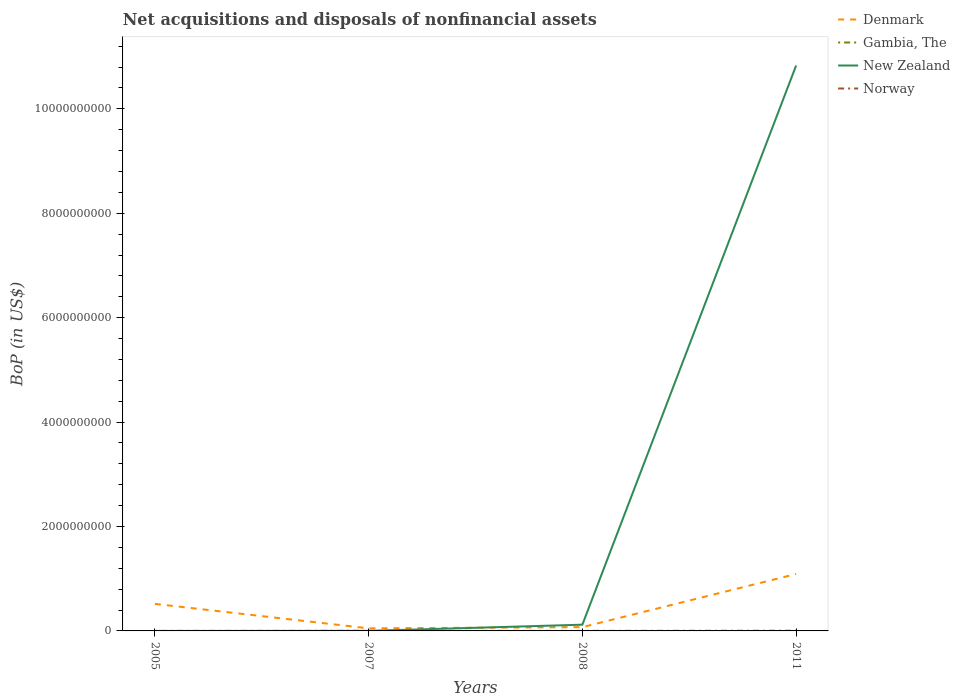How many different coloured lines are there?
Your response must be concise. 3. Is the number of lines equal to the number of legend labels?
Ensure brevity in your answer.  No. Across all years, what is the maximum Balance of Payments in Norway?
Your answer should be very brief. 0. What is the total Balance of Payments in Gambia, The in the graph?
Provide a succinct answer. -3.56e+06. What is the difference between the highest and the second highest Balance of Payments in Denmark?
Offer a very short reply. 1.04e+09. What is the difference between the highest and the lowest Balance of Payments in Norway?
Keep it short and to the point. 0. Is the Balance of Payments in Denmark strictly greater than the Balance of Payments in New Zealand over the years?
Give a very brief answer. No. What is the difference between two consecutive major ticks on the Y-axis?
Make the answer very short. 2.00e+09. Where does the legend appear in the graph?
Offer a terse response. Top right. What is the title of the graph?
Offer a terse response. Net acquisitions and disposals of nonfinancial assets. What is the label or title of the X-axis?
Offer a very short reply. Years. What is the label or title of the Y-axis?
Provide a short and direct response. BoP (in US$). What is the BoP (in US$) of Denmark in 2005?
Your answer should be very brief. 5.18e+08. What is the BoP (in US$) in Gambia, The in 2005?
Provide a short and direct response. 5.98e+05. What is the BoP (in US$) in Norway in 2005?
Your answer should be compact. 0. What is the BoP (in US$) in Denmark in 2007?
Give a very brief answer. 4.93e+07. What is the BoP (in US$) in Gambia, The in 2007?
Make the answer very short. 2.07e+06. What is the BoP (in US$) in New Zealand in 2007?
Provide a succinct answer. 7.64e+05. What is the BoP (in US$) in Norway in 2007?
Your answer should be very brief. 0. What is the BoP (in US$) in Denmark in 2008?
Ensure brevity in your answer.  7.29e+07. What is the BoP (in US$) of Gambia, The in 2008?
Make the answer very short. 1.17e+06. What is the BoP (in US$) of New Zealand in 2008?
Make the answer very short. 1.19e+08. What is the BoP (in US$) in Denmark in 2011?
Ensure brevity in your answer.  1.09e+09. What is the BoP (in US$) in Gambia, The in 2011?
Your response must be concise. 4.15e+06. What is the BoP (in US$) of New Zealand in 2011?
Ensure brevity in your answer.  1.08e+1. Across all years, what is the maximum BoP (in US$) in Denmark?
Your answer should be compact. 1.09e+09. Across all years, what is the maximum BoP (in US$) in Gambia, The?
Provide a succinct answer. 4.15e+06. Across all years, what is the maximum BoP (in US$) in New Zealand?
Provide a succinct answer. 1.08e+1. Across all years, what is the minimum BoP (in US$) of Denmark?
Offer a very short reply. 4.93e+07. Across all years, what is the minimum BoP (in US$) in Gambia, The?
Make the answer very short. 5.98e+05. What is the total BoP (in US$) of Denmark in the graph?
Keep it short and to the point. 1.73e+09. What is the total BoP (in US$) of Gambia, The in the graph?
Offer a very short reply. 7.99e+06. What is the total BoP (in US$) in New Zealand in the graph?
Provide a short and direct response. 1.09e+1. What is the difference between the BoP (in US$) in Denmark in 2005 and that in 2007?
Give a very brief answer. 4.69e+08. What is the difference between the BoP (in US$) of Gambia, The in 2005 and that in 2007?
Provide a succinct answer. -1.47e+06. What is the difference between the BoP (in US$) in Denmark in 2005 and that in 2008?
Offer a very short reply. 4.45e+08. What is the difference between the BoP (in US$) in Gambia, The in 2005 and that in 2008?
Your response must be concise. -5.74e+05. What is the difference between the BoP (in US$) in Denmark in 2005 and that in 2011?
Give a very brief answer. -5.72e+08. What is the difference between the BoP (in US$) of Gambia, The in 2005 and that in 2011?
Provide a succinct answer. -3.56e+06. What is the difference between the BoP (in US$) in Denmark in 2007 and that in 2008?
Keep it short and to the point. -2.35e+07. What is the difference between the BoP (in US$) of Gambia, The in 2007 and that in 2008?
Your response must be concise. 8.96e+05. What is the difference between the BoP (in US$) in New Zealand in 2007 and that in 2008?
Make the answer very short. -1.19e+08. What is the difference between the BoP (in US$) in Denmark in 2007 and that in 2011?
Ensure brevity in your answer.  -1.04e+09. What is the difference between the BoP (in US$) of Gambia, The in 2007 and that in 2011?
Provide a short and direct response. -2.09e+06. What is the difference between the BoP (in US$) in New Zealand in 2007 and that in 2011?
Offer a terse response. -1.08e+1. What is the difference between the BoP (in US$) in Denmark in 2008 and that in 2011?
Provide a succinct answer. -1.02e+09. What is the difference between the BoP (in US$) in Gambia, The in 2008 and that in 2011?
Your answer should be compact. -2.98e+06. What is the difference between the BoP (in US$) in New Zealand in 2008 and that in 2011?
Provide a succinct answer. -1.07e+1. What is the difference between the BoP (in US$) in Denmark in 2005 and the BoP (in US$) in Gambia, The in 2007?
Keep it short and to the point. 5.16e+08. What is the difference between the BoP (in US$) of Denmark in 2005 and the BoP (in US$) of New Zealand in 2007?
Your response must be concise. 5.17e+08. What is the difference between the BoP (in US$) of Gambia, The in 2005 and the BoP (in US$) of New Zealand in 2007?
Your answer should be very brief. -1.65e+05. What is the difference between the BoP (in US$) of Denmark in 2005 and the BoP (in US$) of Gambia, The in 2008?
Your answer should be compact. 5.17e+08. What is the difference between the BoP (in US$) in Denmark in 2005 and the BoP (in US$) in New Zealand in 2008?
Provide a short and direct response. 3.99e+08. What is the difference between the BoP (in US$) in Gambia, The in 2005 and the BoP (in US$) in New Zealand in 2008?
Provide a succinct answer. -1.19e+08. What is the difference between the BoP (in US$) in Denmark in 2005 and the BoP (in US$) in Gambia, The in 2011?
Offer a terse response. 5.14e+08. What is the difference between the BoP (in US$) of Denmark in 2005 and the BoP (in US$) of New Zealand in 2011?
Make the answer very short. -1.03e+1. What is the difference between the BoP (in US$) of Gambia, The in 2005 and the BoP (in US$) of New Zealand in 2011?
Offer a terse response. -1.08e+1. What is the difference between the BoP (in US$) of Denmark in 2007 and the BoP (in US$) of Gambia, The in 2008?
Keep it short and to the point. 4.81e+07. What is the difference between the BoP (in US$) of Denmark in 2007 and the BoP (in US$) of New Zealand in 2008?
Keep it short and to the point. -7.01e+07. What is the difference between the BoP (in US$) in Gambia, The in 2007 and the BoP (in US$) in New Zealand in 2008?
Your answer should be compact. -1.17e+08. What is the difference between the BoP (in US$) in Denmark in 2007 and the BoP (in US$) in Gambia, The in 2011?
Your answer should be very brief. 4.52e+07. What is the difference between the BoP (in US$) in Denmark in 2007 and the BoP (in US$) in New Zealand in 2011?
Keep it short and to the point. -1.08e+1. What is the difference between the BoP (in US$) in Gambia, The in 2007 and the BoP (in US$) in New Zealand in 2011?
Your answer should be very brief. -1.08e+1. What is the difference between the BoP (in US$) in Denmark in 2008 and the BoP (in US$) in Gambia, The in 2011?
Give a very brief answer. 6.87e+07. What is the difference between the BoP (in US$) in Denmark in 2008 and the BoP (in US$) in New Zealand in 2011?
Offer a terse response. -1.08e+1. What is the difference between the BoP (in US$) of Gambia, The in 2008 and the BoP (in US$) of New Zealand in 2011?
Offer a terse response. -1.08e+1. What is the average BoP (in US$) of Denmark per year?
Your response must be concise. 4.33e+08. What is the average BoP (in US$) of Gambia, The per year?
Give a very brief answer. 2.00e+06. What is the average BoP (in US$) of New Zealand per year?
Your answer should be compact. 2.74e+09. In the year 2005, what is the difference between the BoP (in US$) of Denmark and BoP (in US$) of Gambia, The?
Give a very brief answer. 5.17e+08. In the year 2007, what is the difference between the BoP (in US$) in Denmark and BoP (in US$) in Gambia, The?
Provide a short and direct response. 4.72e+07. In the year 2007, what is the difference between the BoP (in US$) in Denmark and BoP (in US$) in New Zealand?
Provide a succinct answer. 4.85e+07. In the year 2007, what is the difference between the BoP (in US$) of Gambia, The and BoP (in US$) of New Zealand?
Your answer should be very brief. 1.30e+06. In the year 2008, what is the difference between the BoP (in US$) of Denmark and BoP (in US$) of Gambia, The?
Give a very brief answer. 7.17e+07. In the year 2008, what is the difference between the BoP (in US$) of Denmark and BoP (in US$) of New Zealand?
Your answer should be very brief. -4.66e+07. In the year 2008, what is the difference between the BoP (in US$) in Gambia, The and BoP (in US$) in New Zealand?
Ensure brevity in your answer.  -1.18e+08. In the year 2011, what is the difference between the BoP (in US$) in Denmark and BoP (in US$) in Gambia, The?
Your answer should be very brief. 1.09e+09. In the year 2011, what is the difference between the BoP (in US$) in Denmark and BoP (in US$) in New Zealand?
Give a very brief answer. -9.74e+09. In the year 2011, what is the difference between the BoP (in US$) of Gambia, The and BoP (in US$) of New Zealand?
Offer a very short reply. -1.08e+1. What is the ratio of the BoP (in US$) in Denmark in 2005 to that in 2007?
Your answer should be very brief. 10.5. What is the ratio of the BoP (in US$) of Gambia, The in 2005 to that in 2007?
Keep it short and to the point. 0.29. What is the ratio of the BoP (in US$) in Denmark in 2005 to that in 2008?
Offer a very short reply. 7.11. What is the ratio of the BoP (in US$) of Gambia, The in 2005 to that in 2008?
Your response must be concise. 0.51. What is the ratio of the BoP (in US$) in Denmark in 2005 to that in 2011?
Provide a short and direct response. 0.48. What is the ratio of the BoP (in US$) of Gambia, The in 2005 to that in 2011?
Offer a very short reply. 0.14. What is the ratio of the BoP (in US$) in Denmark in 2007 to that in 2008?
Offer a terse response. 0.68. What is the ratio of the BoP (in US$) of Gambia, The in 2007 to that in 2008?
Keep it short and to the point. 1.76. What is the ratio of the BoP (in US$) of New Zealand in 2007 to that in 2008?
Your answer should be very brief. 0.01. What is the ratio of the BoP (in US$) of Denmark in 2007 to that in 2011?
Provide a succinct answer. 0.05. What is the ratio of the BoP (in US$) of Gambia, The in 2007 to that in 2011?
Your response must be concise. 0.5. What is the ratio of the BoP (in US$) in Denmark in 2008 to that in 2011?
Your answer should be very brief. 0.07. What is the ratio of the BoP (in US$) in Gambia, The in 2008 to that in 2011?
Keep it short and to the point. 0.28. What is the ratio of the BoP (in US$) of New Zealand in 2008 to that in 2011?
Provide a succinct answer. 0.01. What is the difference between the highest and the second highest BoP (in US$) of Denmark?
Provide a succinct answer. 5.72e+08. What is the difference between the highest and the second highest BoP (in US$) of Gambia, The?
Give a very brief answer. 2.09e+06. What is the difference between the highest and the second highest BoP (in US$) in New Zealand?
Keep it short and to the point. 1.07e+1. What is the difference between the highest and the lowest BoP (in US$) in Denmark?
Offer a terse response. 1.04e+09. What is the difference between the highest and the lowest BoP (in US$) of Gambia, The?
Your answer should be very brief. 3.56e+06. What is the difference between the highest and the lowest BoP (in US$) of New Zealand?
Provide a short and direct response. 1.08e+1. 